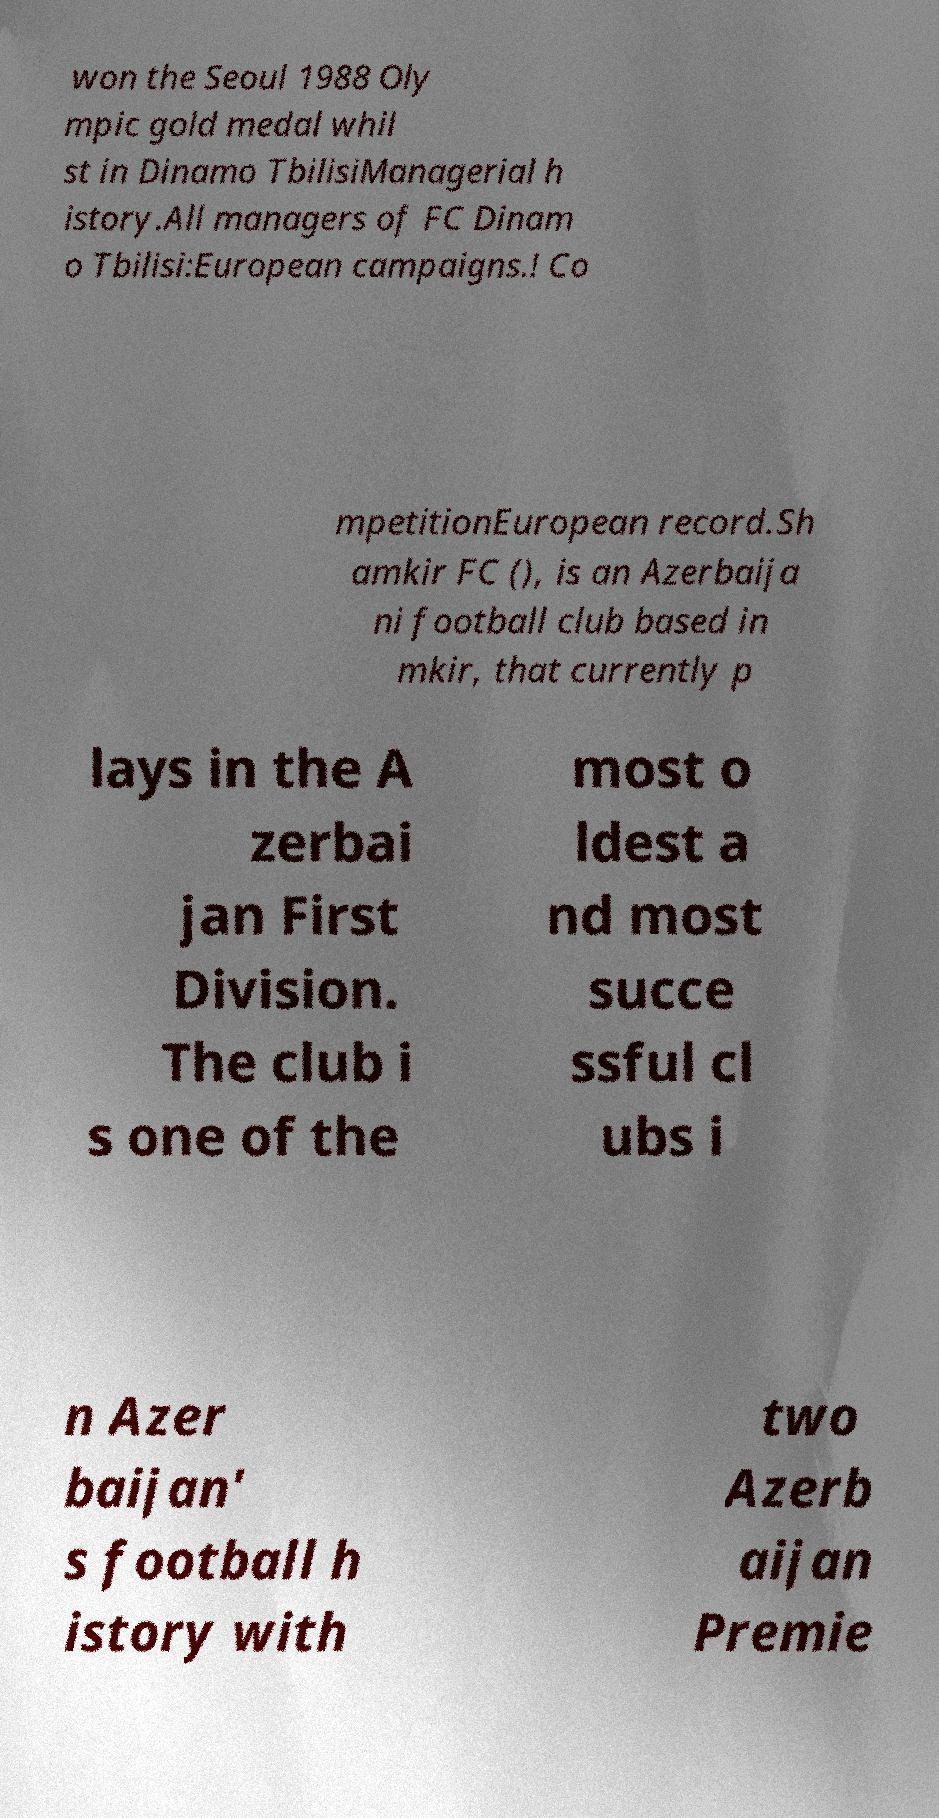For documentation purposes, I need the text within this image transcribed. Could you provide that? won the Seoul 1988 Oly mpic gold medal whil st in Dinamo TbilisiManagerial h istory.All managers of FC Dinam o Tbilisi:European campaigns.! Co mpetitionEuropean record.Sh amkir FC (), is an Azerbaija ni football club based in mkir, that currently p lays in the A zerbai jan First Division. The club i s one of the most o ldest a nd most succe ssful cl ubs i n Azer baijan' s football h istory with two Azerb aijan Premie 